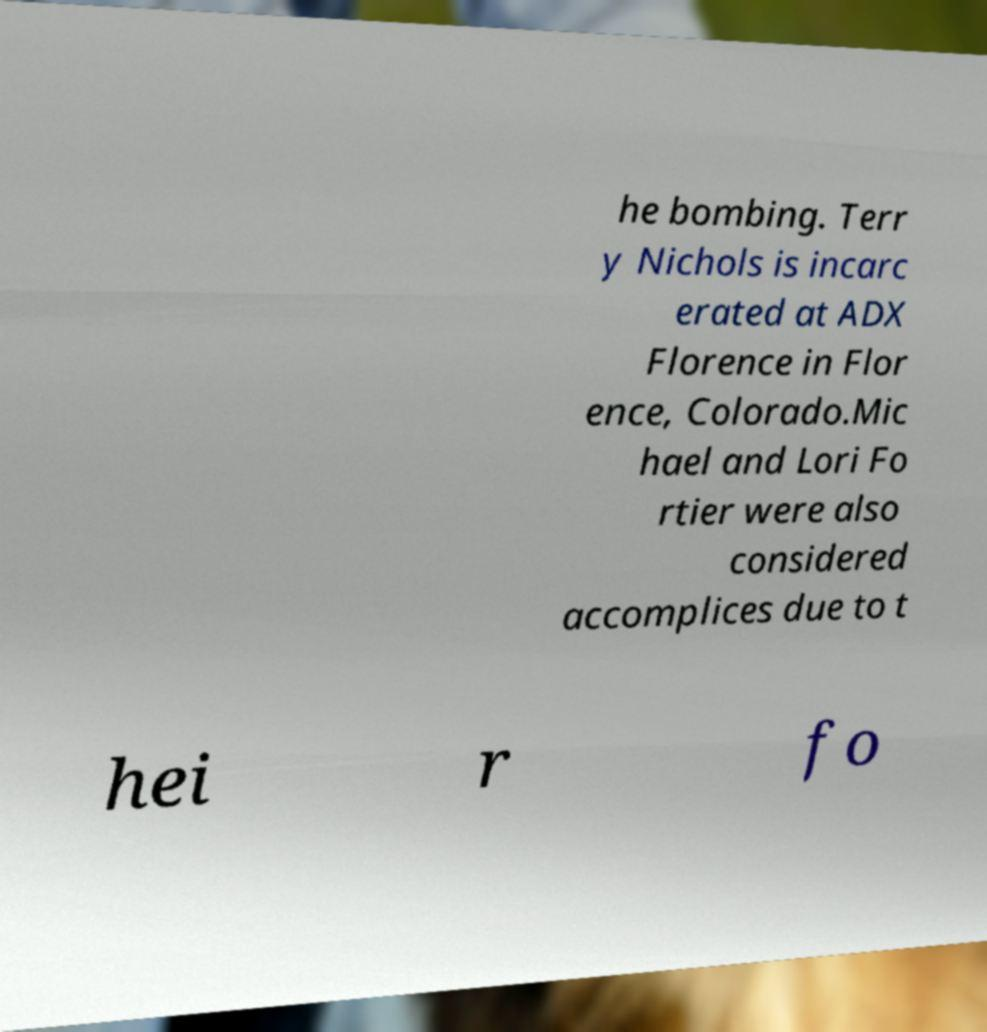Please identify and transcribe the text found in this image. he bombing. Terr y Nichols is incarc erated at ADX Florence in Flor ence, Colorado.Mic hael and Lori Fo rtier were also considered accomplices due to t hei r fo 